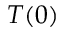Convert formula to latex. <formula><loc_0><loc_0><loc_500><loc_500>T ( 0 )</formula> 